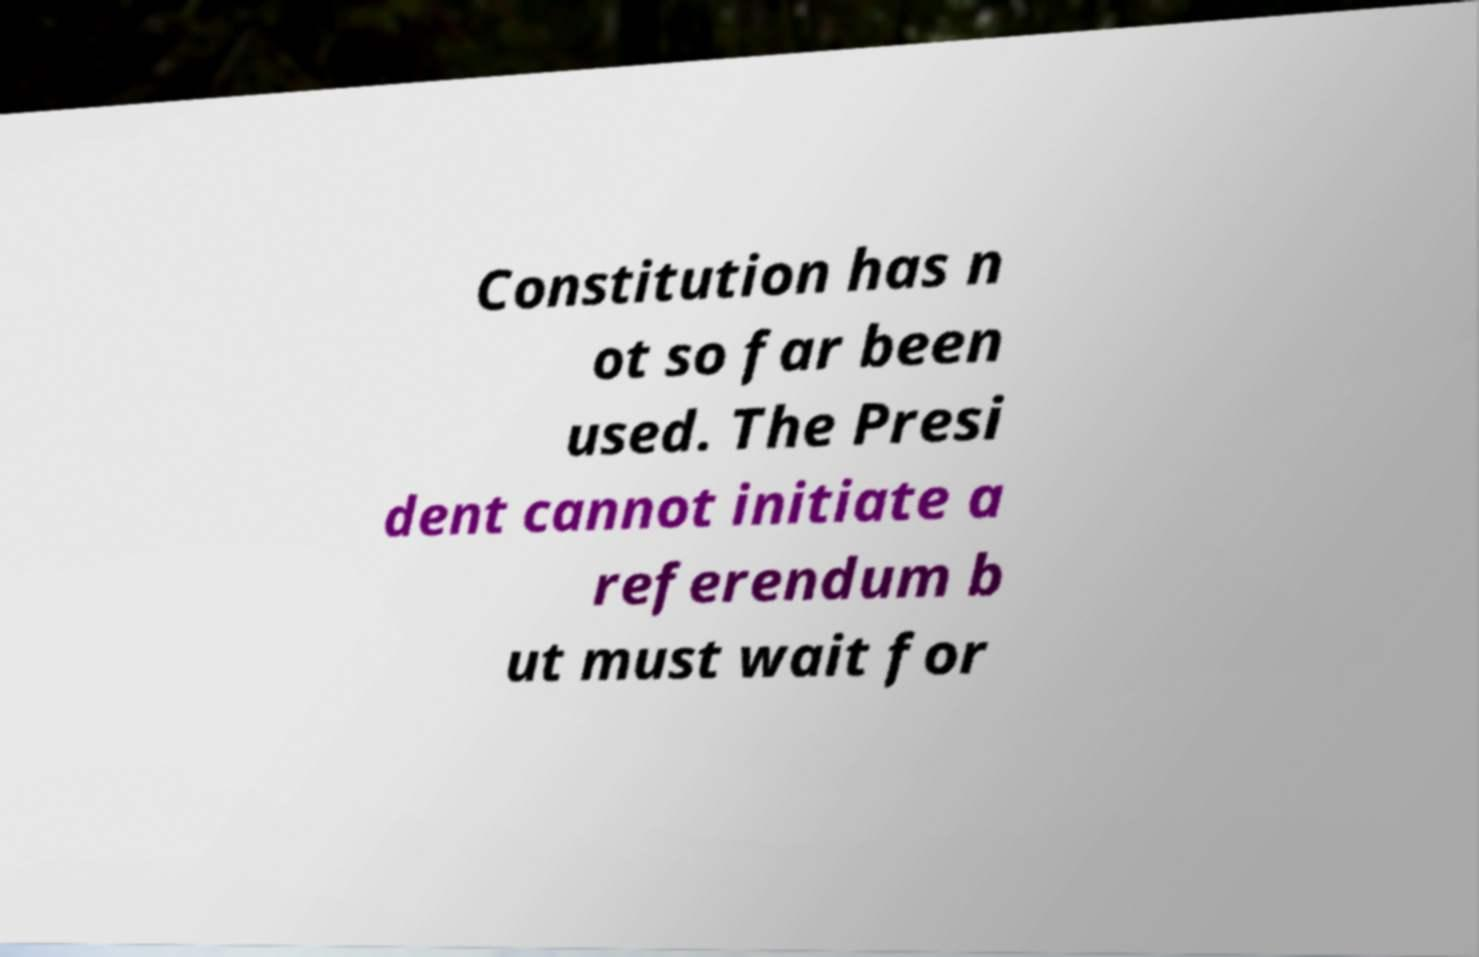There's text embedded in this image that I need extracted. Can you transcribe it verbatim? Constitution has n ot so far been used. The Presi dent cannot initiate a referendum b ut must wait for 